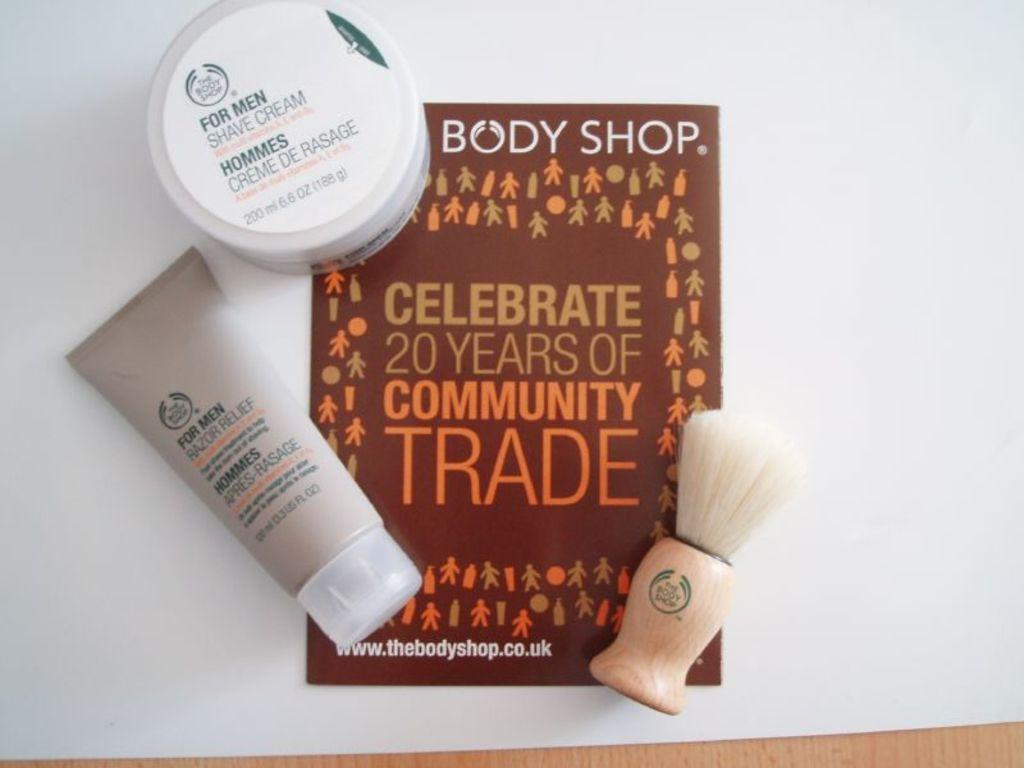Provide a one-sentence caption for the provided image. Body Shop Celebrate 20 yers of community trade book with 3 lotions. 